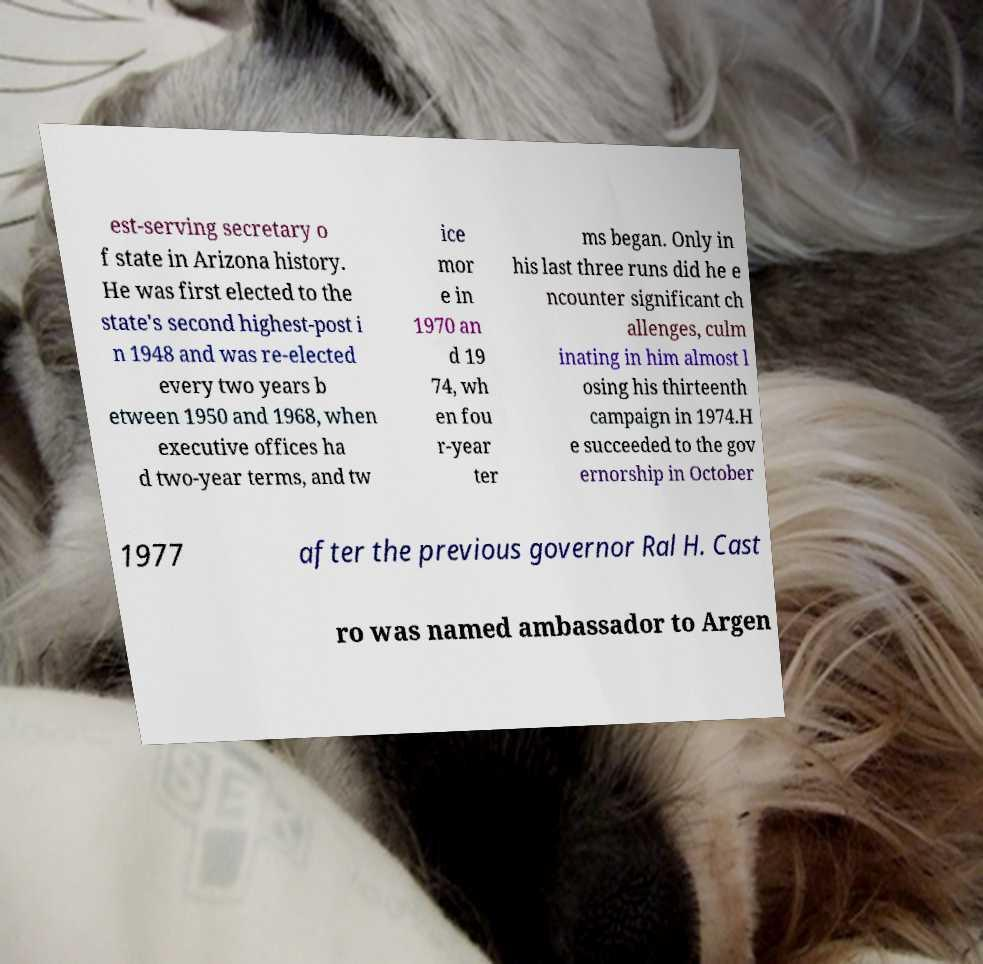Can you accurately transcribe the text from the provided image for me? est-serving secretary o f state in Arizona history. He was first elected to the state's second highest-post i n 1948 and was re-elected every two years b etween 1950 and 1968, when executive offices ha d two-year terms, and tw ice mor e in 1970 an d 19 74, wh en fou r-year ter ms began. Only in his last three runs did he e ncounter significant ch allenges, culm inating in him almost l osing his thirteenth campaign in 1974.H e succeeded to the gov ernorship in October 1977 after the previous governor Ral H. Cast ro was named ambassador to Argen 